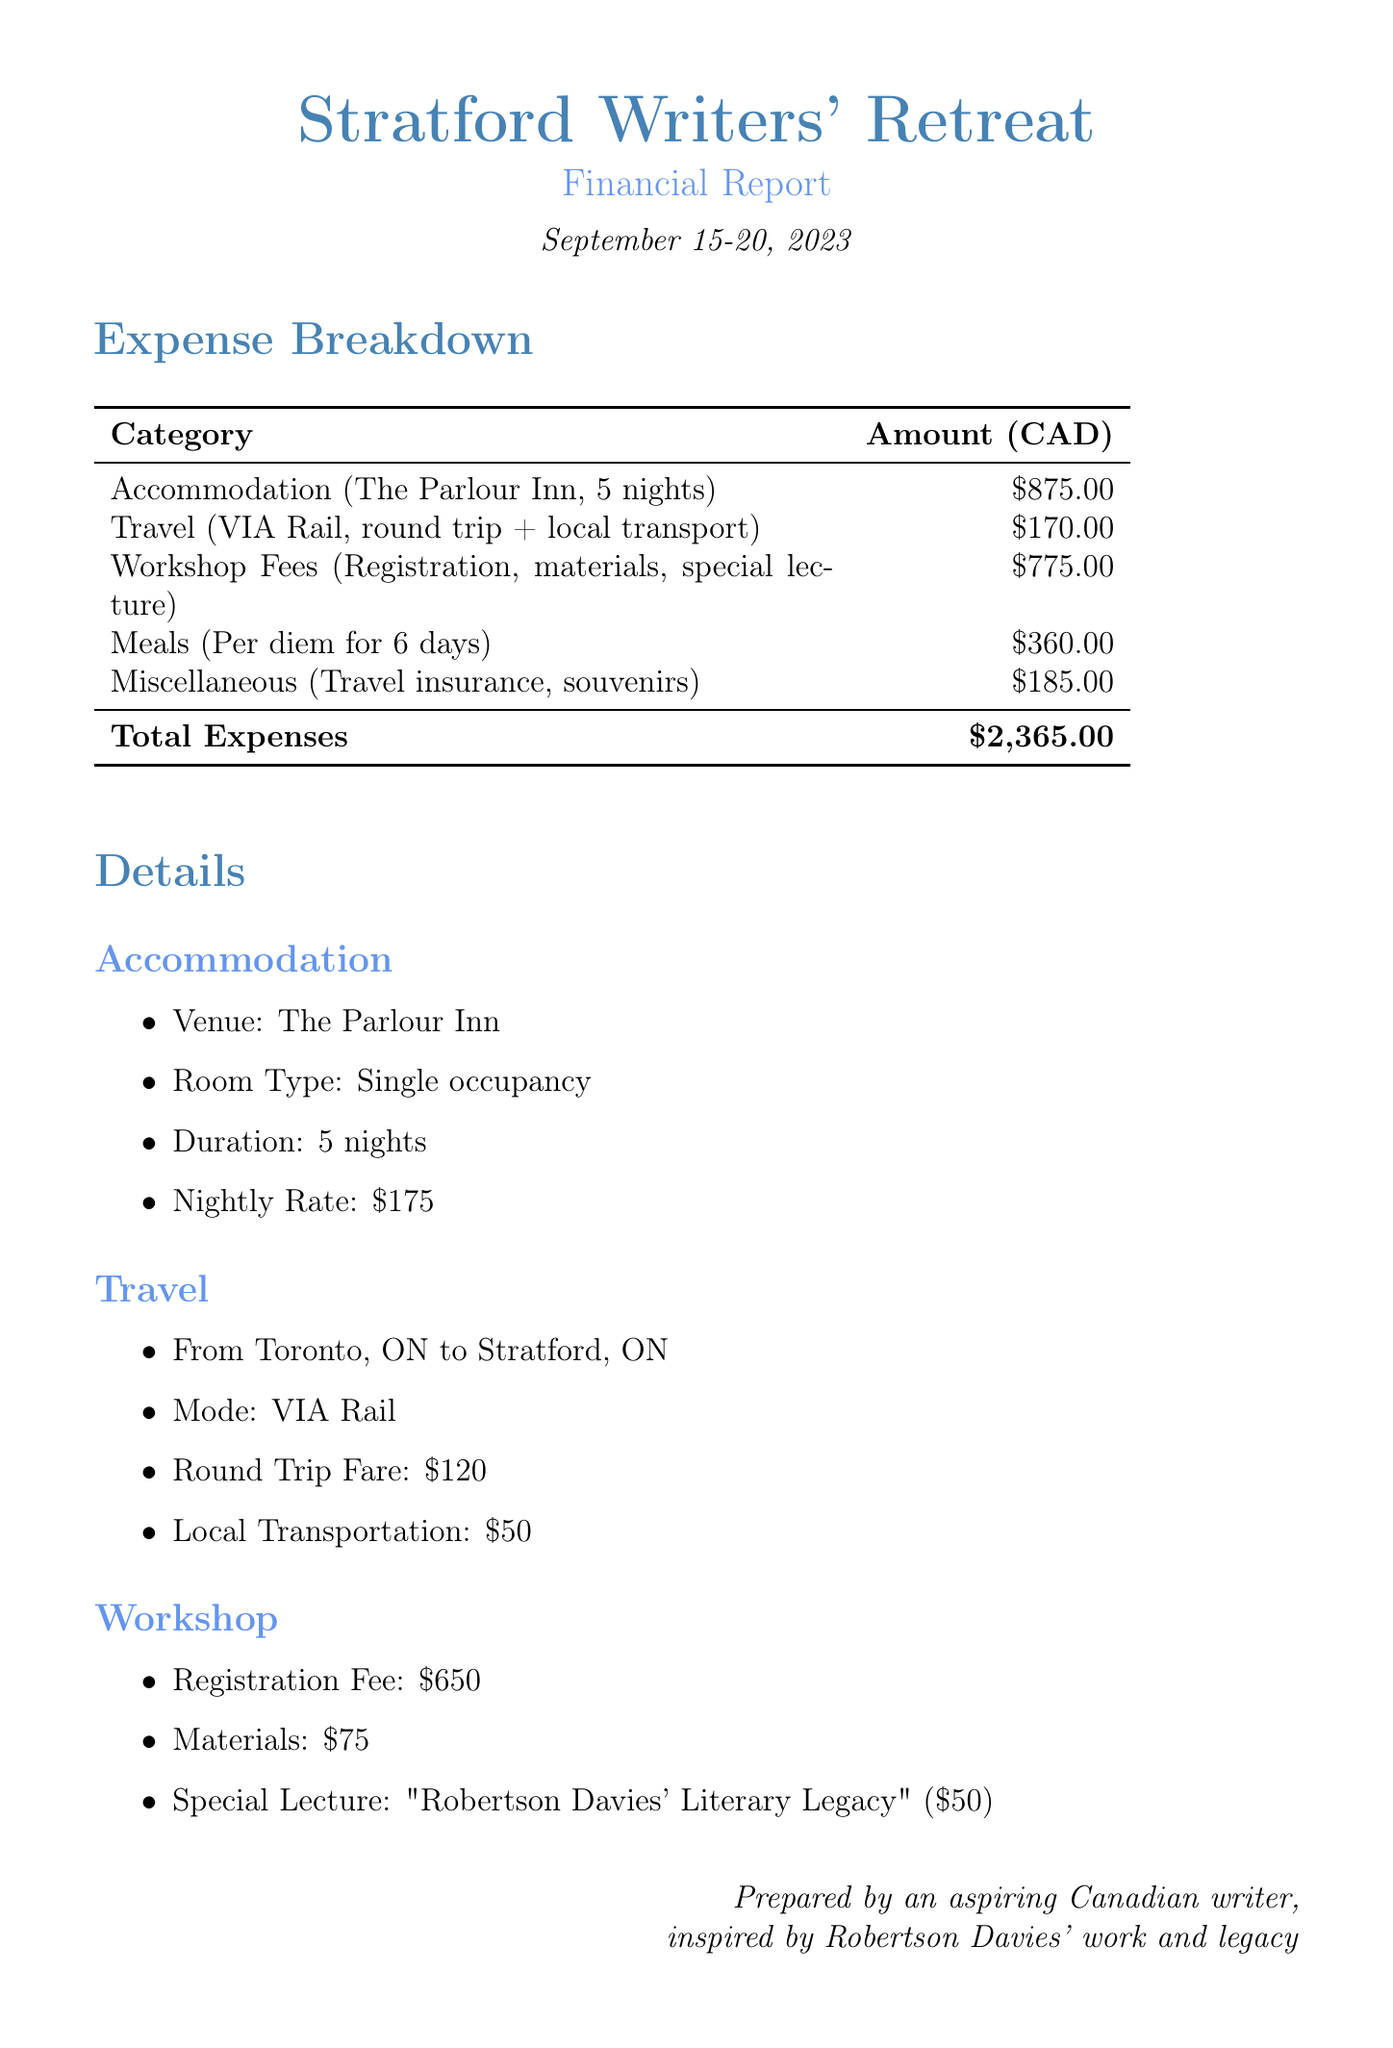What is the name of the retreat? The name of the retreat is presented in the document's title section, emphasizing its identity.
Answer: Stratford Writers' Retreat What is the total amount spent on meals? The total amount spent on meals is calculated from the per diem rate and number of days.
Answer: $360.00 What is the round trip fare for travel? The document lists the round trip fare separately under the travel section.
Answer: $120 How many nights was accommodation provided? The accommodation section clearly states the duration of the stay in nights.
Answer: 5 nights What was the special lecture titled? The title of the special lecture is explicitly mentioned in the workshop section.
Answer: Robertson Davies' Literary Legacy What is the subtotal for accommodation? The subtotal for accommodation is found in the expense breakdown which summarizes costs.
Answer: $875.00 What is the total amount of miscellaneous expenses? The total of miscellaneous expenses is derived from the items listed in that section.
Answer: $185.00 How much was spent on workshop registration? This specific fee is detailed in the workshop section as part of the overall costs.
Answer: $650 What mode of transportation was used to travel to the retreat? The document specifies the mode of travel used as stated in the travel section.
Answer: VIA Rail 